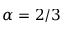<formula> <loc_0><loc_0><loc_500><loc_500>\alpha = 2 / 3</formula> 